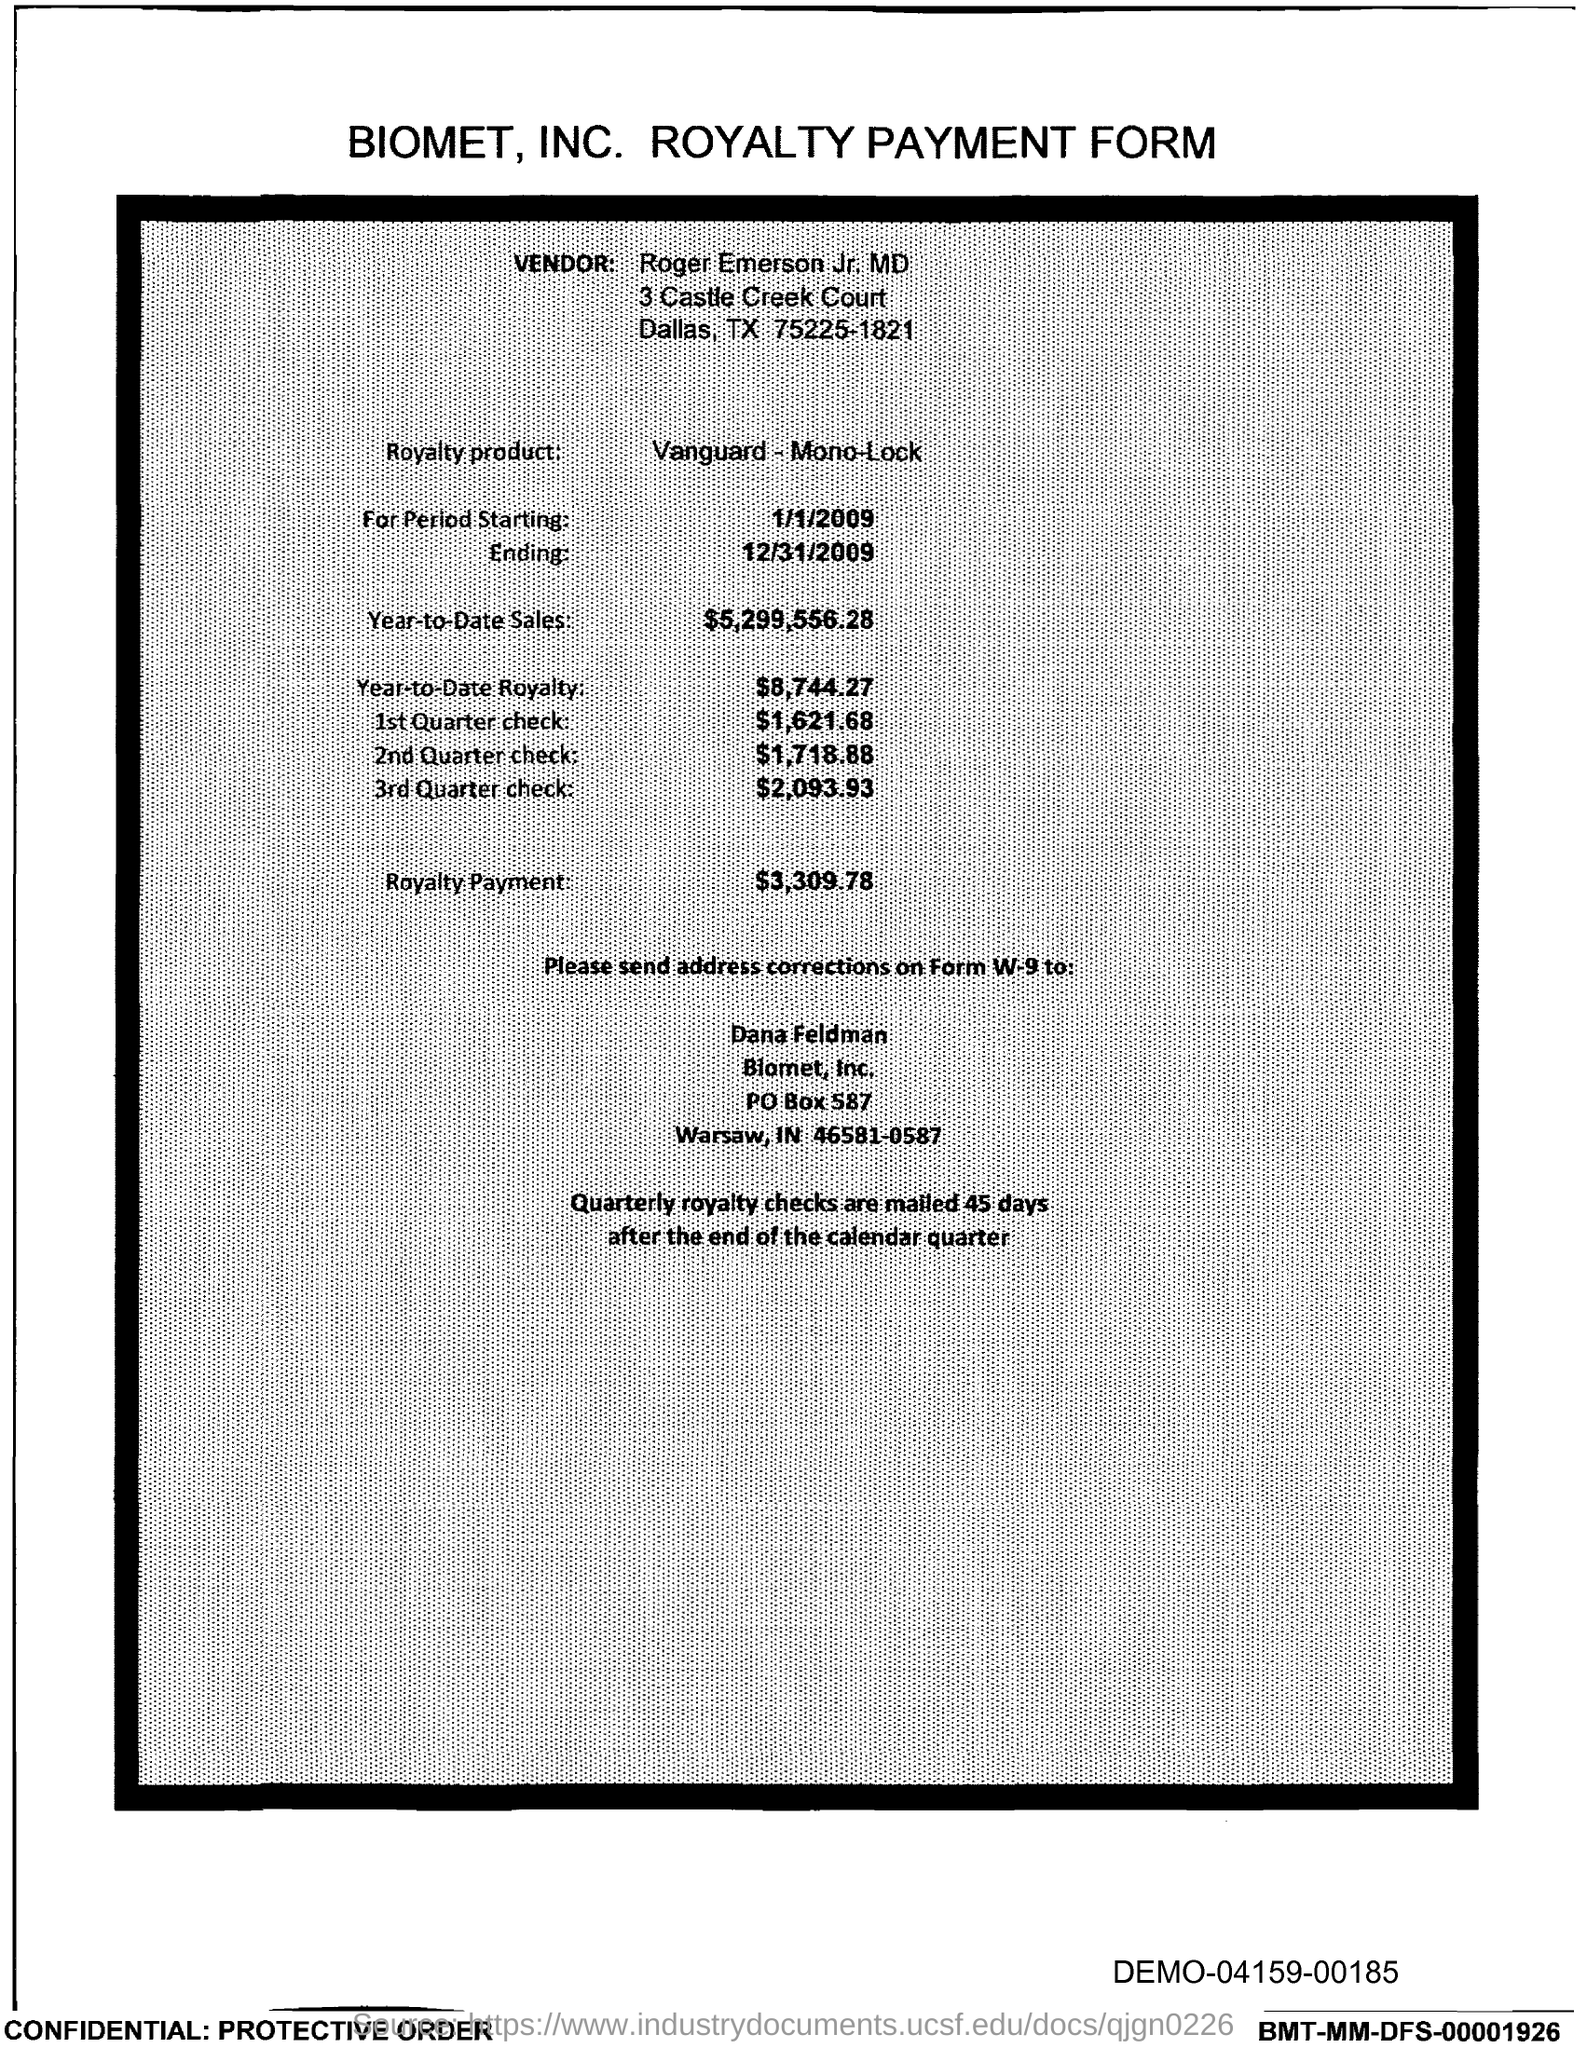Draw attention to some important aspects in this diagram. The document mentions a PO Box Number as 587. 